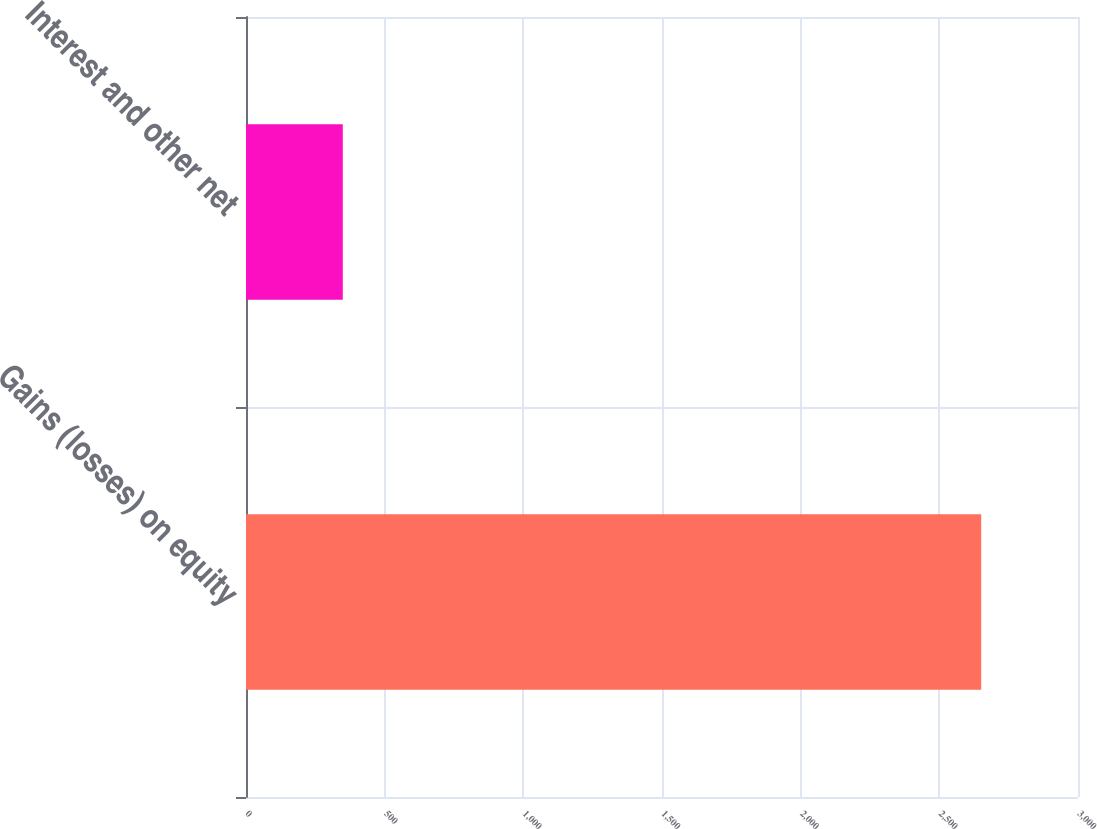Convert chart. <chart><loc_0><loc_0><loc_500><loc_500><bar_chart><fcel>Gains (losses) on equity<fcel>Interest and other net<nl><fcel>2651<fcel>349<nl></chart> 